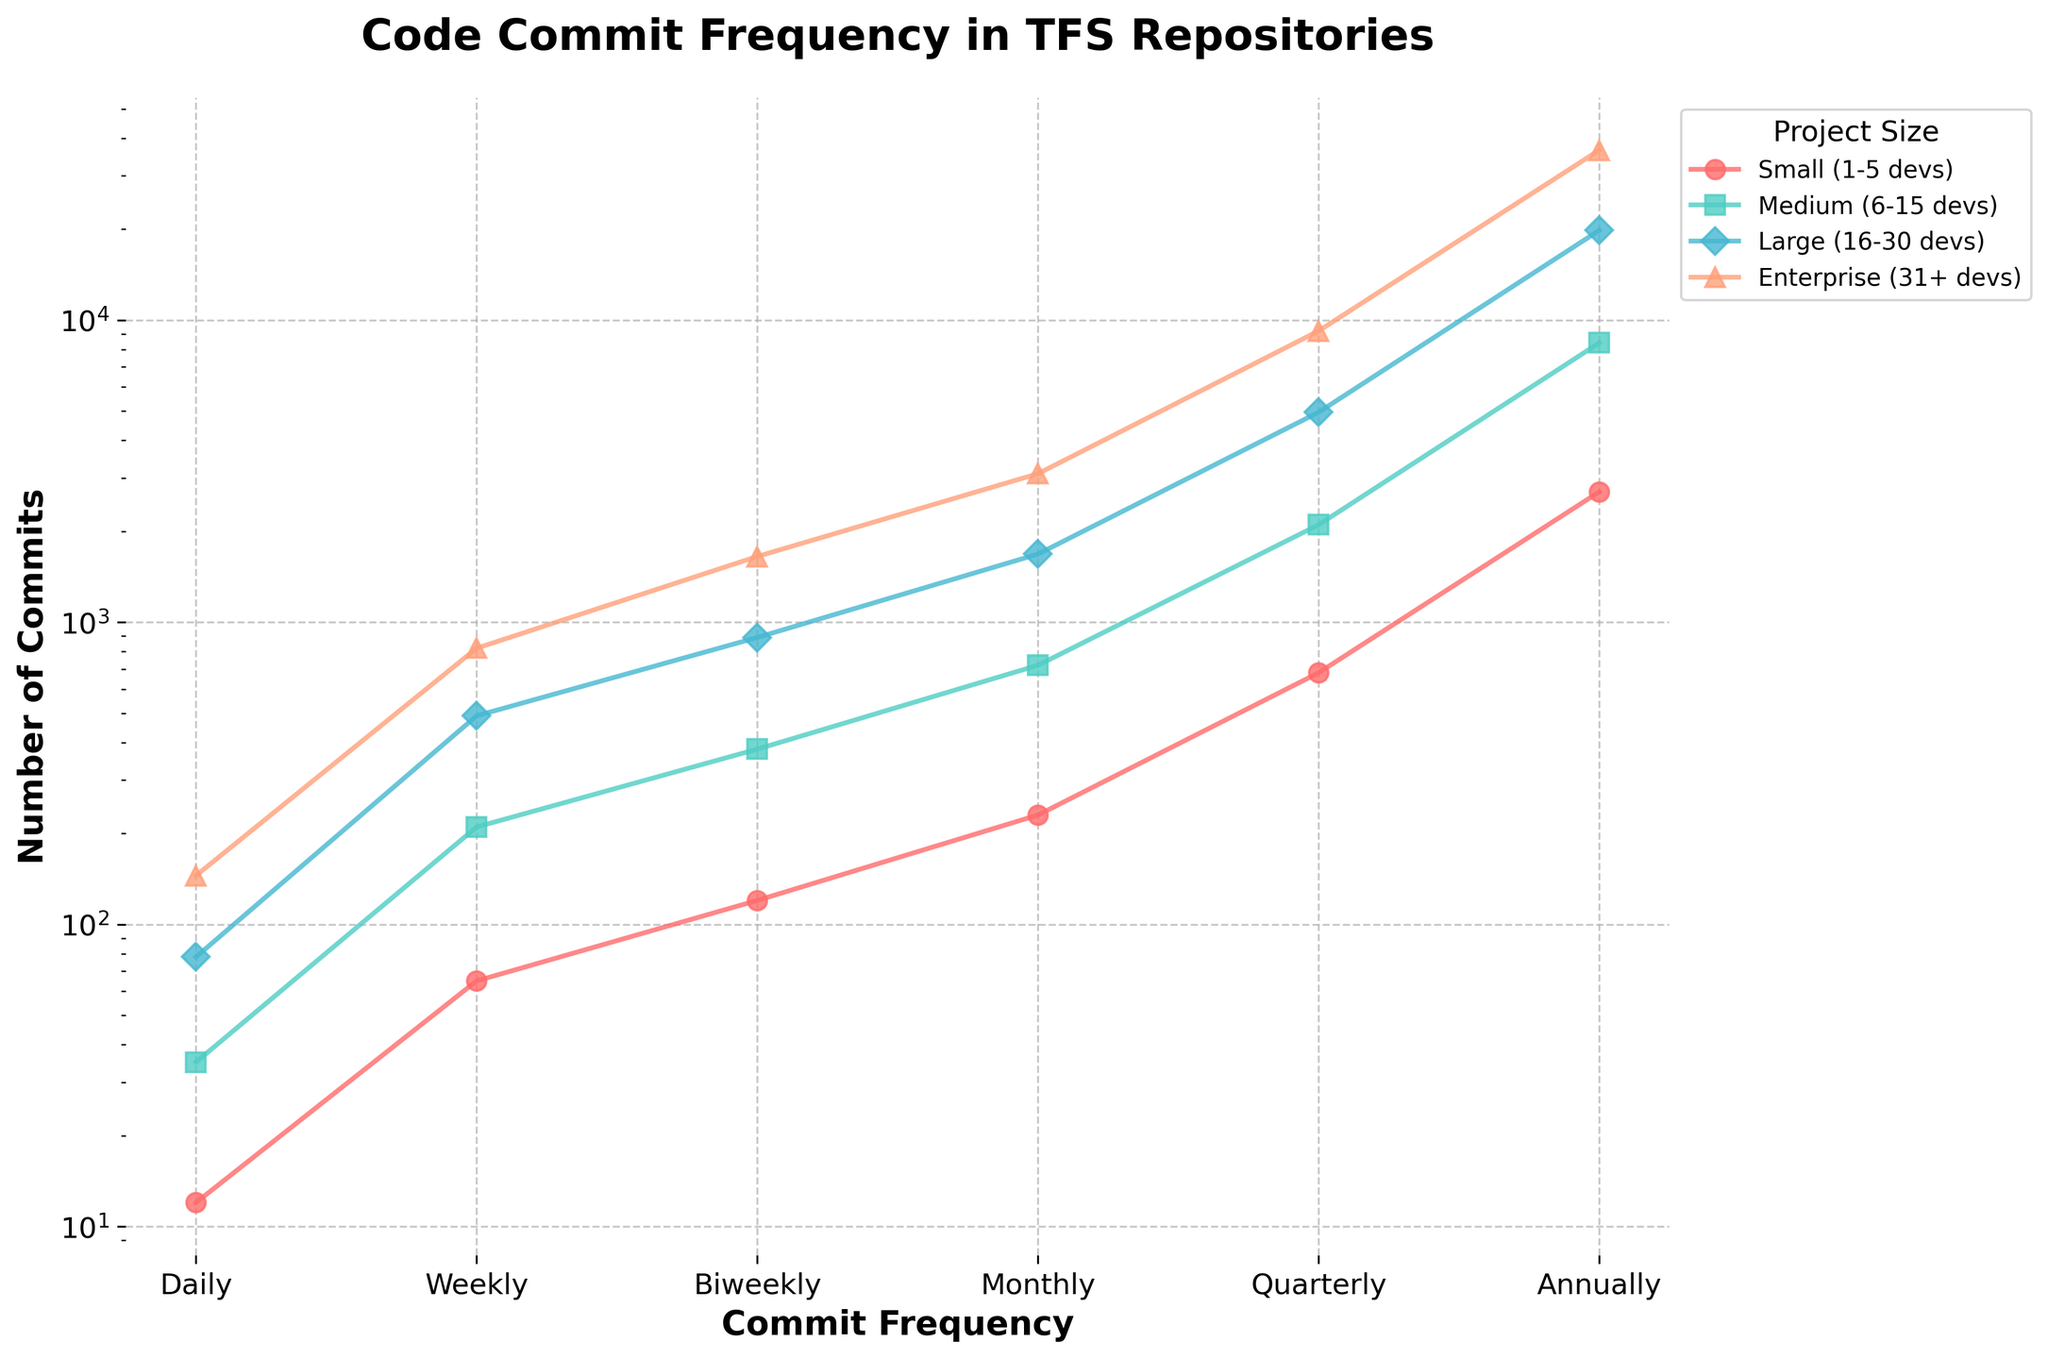What is the general trend in the number of commits as the project size increases from Small to Enterprise? As the project size increases from Small to Enterprise, the plotted lines show a consistent increase in the number of commits across each commit frequency category (Daily, Weekly, Biweekly, Monthly, Quarterly, Annually). This indicates that larger projects have higher commit frequencies.
Answer: Larger projects have higher commit frequencies Which project size has the highest number of commits for Quarterly frequency? Looking at the plotted lines, the Enterprise project size (represented by a specific line) shows the highest value for Quarterly commit frequency.
Answer: Enterprise For biweekly commits, how many more commits are there in Enterprise projects compared to Small projects? The number of biweekly commits for Enterprise projects is 1650, and for Small projects, it is 120. The difference is 1650 - 120.
Answer: 1530 What is the difference in the number of annual commits between Medium and Large project sizes? The number of annual commits for Medium projects is 8400, and for Large projects, it is 19800. The difference is 19800 - 8400.
Answer: 11400 How many times more are the monthly commits for Medium projects compared to Small projects? The number of monthly commits for Medium projects is 720, and for Small projects, it is 230. The ratio is 720 / 230.
Answer: Approximately 3.13 times Which project size and commit frequency combination results in the steepest increase in the number of commits? Observing the steepness of the lines, the line for Enterprise projects at the Annual commit frequency shows the largest increase, indicating the steepest slope.
Answer: Enterprise projects at Annual frequency What is the closest visual similarity in commit trends between any two project sizes? The commit frequencies for Small and Medium projects show a closer visual trend compared to the others; their lines are relatively closer and follow a similar pattern, albeit Medium projects have higher values.
Answer: Small and Medium Which commit frequency has the least variation in the number of commits across different project sizes? By observing the overlapping or close proximity of values, the Daily commit frequency shows the least variation in commit counts across project sizes.
Answer: Daily 